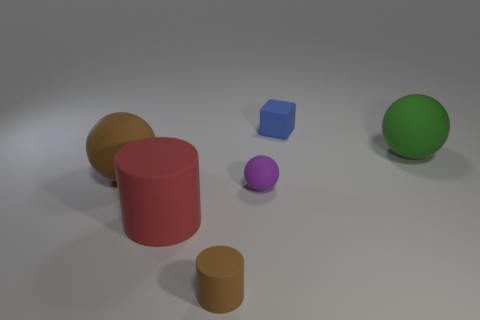Is the color of the large matte sphere to the left of the big green matte sphere the same as the small rubber object that is to the left of the purple thing?
Make the answer very short. Yes. Are there any other things that are the same color as the tiny matte cylinder?
Ensure brevity in your answer.  Yes. What color is the large ball behind the ball that is to the left of the big red cylinder?
Your answer should be very brief. Green. Are there any red cylinders?
Your answer should be very brief. Yes. There is a sphere that is both to the right of the red cylinder and left of the large green rubber ball; what is its color?
Keep it short and to the point. Purple. Do the rubber object behind the green rubber object and the brown object that is to the right of the brown matte sphere have the same size?
Make the answer very short. Yes. What number of other things are there of the same size as the green rubber sphere?
Give a very brief answer. 2. How many brown cylinders are behind the brown rubber thing behind the purple sphere?
Your answer should be very brief. 0. Are there fewer green things that are left of the tiny rubber sphere than big red cylinders?
Ensure brevity in your answer.  Yes. The object to the right of the small matte object behind the large matte object to the right of the tiny purple thing is what shape?
Ensure brevity in your answer.  Sphere. 